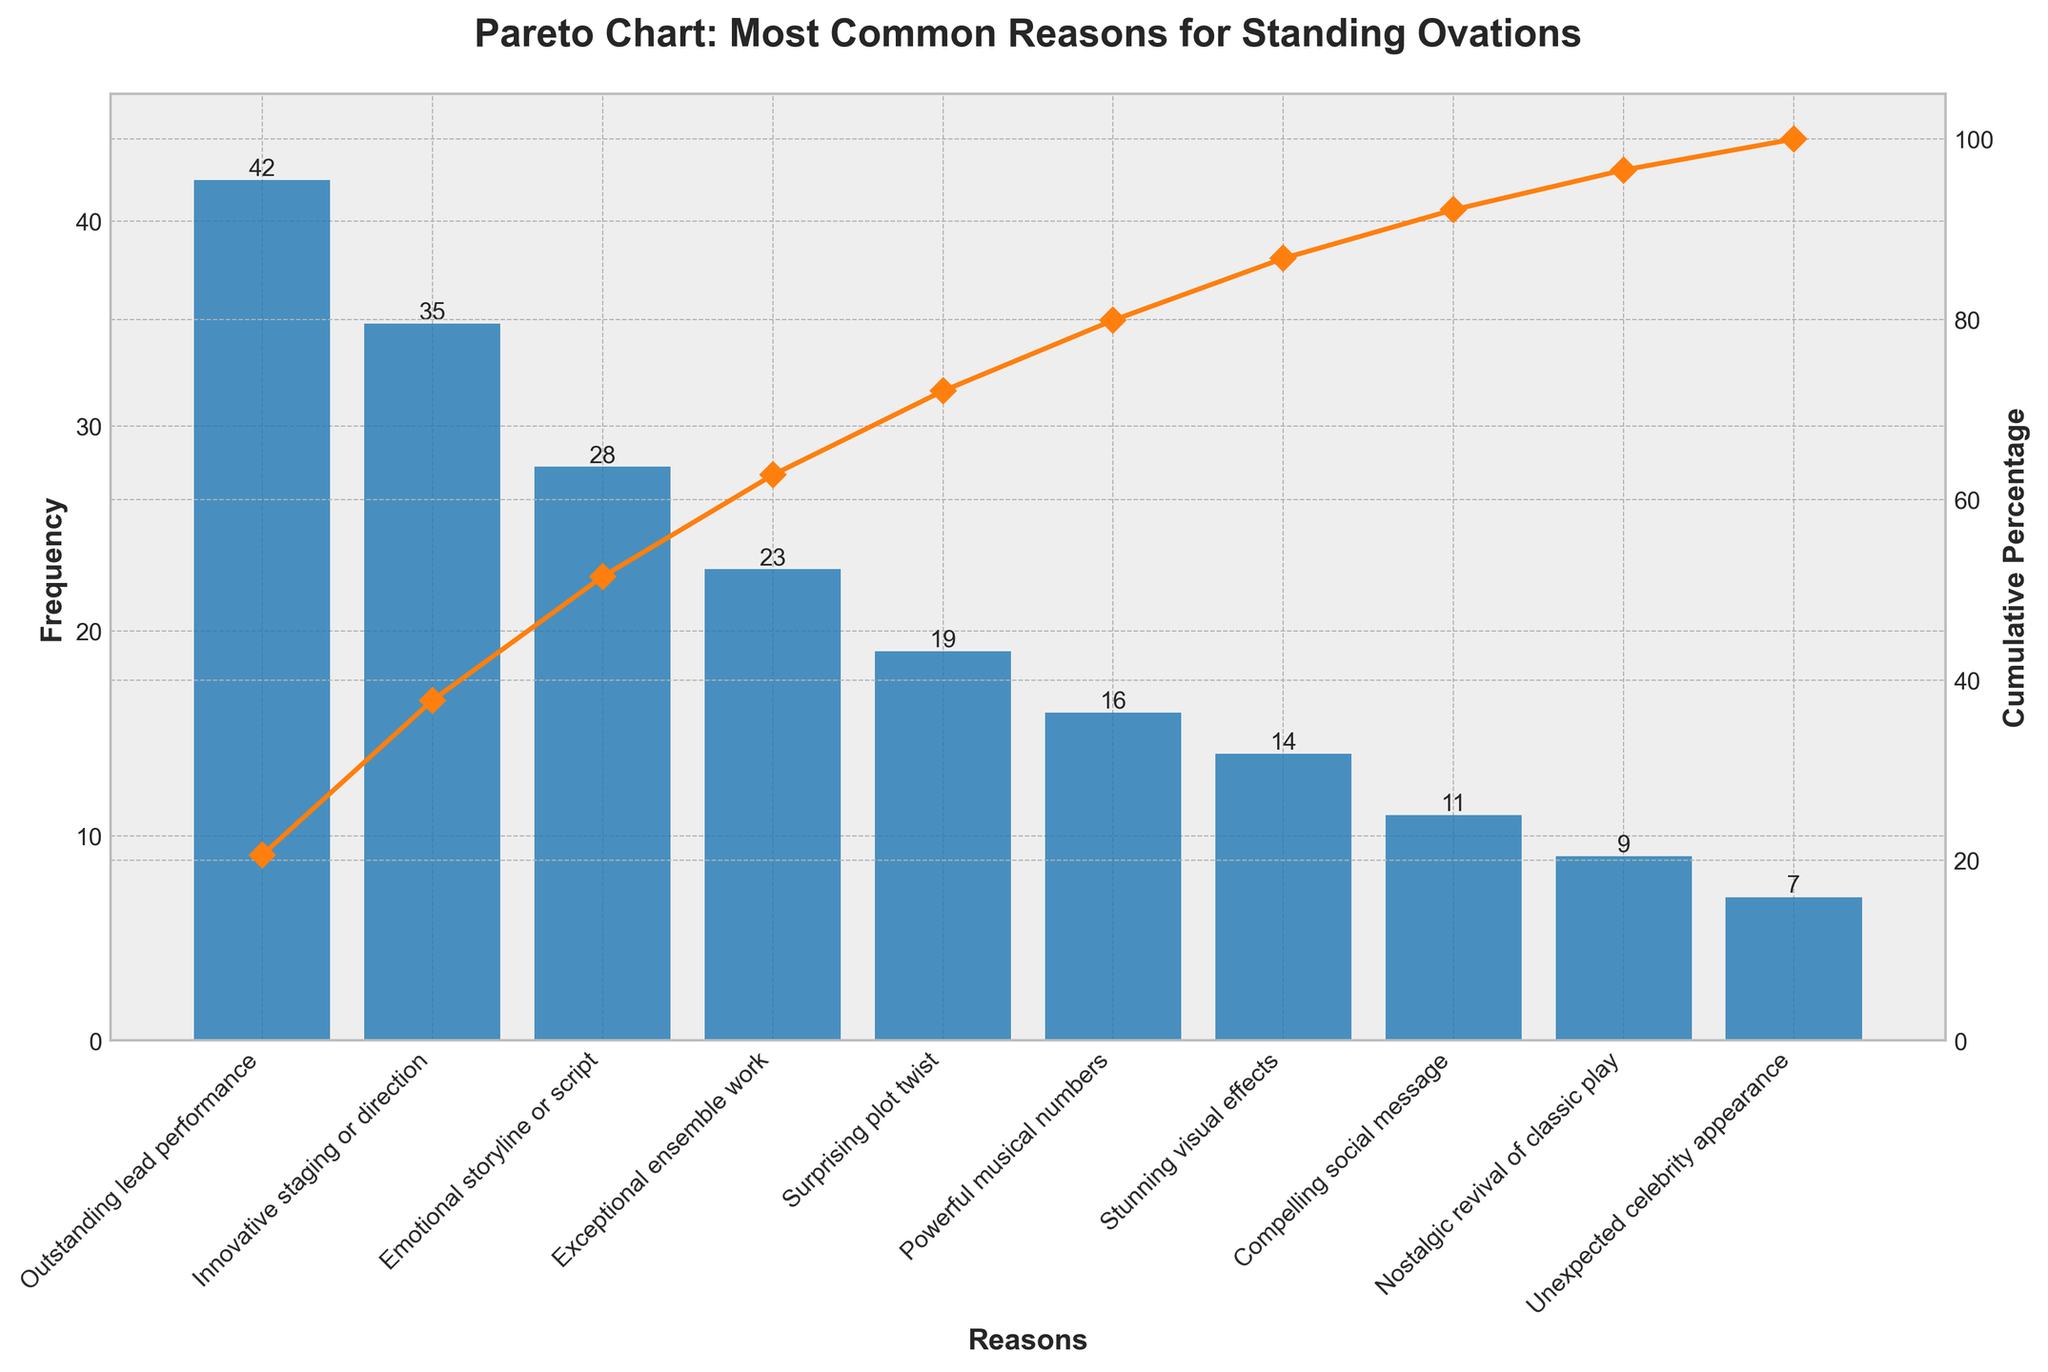What is the title of the chart? The title is displayed at the top of the graph in large, bold text.
Answer: Pareto Chart: Most Common Reasons for Standing Ovations What is the range of the cumulative percentage axis? The right y-axis denotes the cumulative percentage ranging from 0% to 105%.
Answer: 0% to 105% Which reason has the highest frequency for standing ovations? The highest bar on the chart represents the reason with the highest frequency.
Answer: Outstanding lead performance How many reasons account for more than 50% of the cumulative percentage? To find this, identify the reasons whose cumulative percentage sums up to just over 50%. It involves looking at the cumulative percentage line.
Answer: Three reasons What is the cumulative percentage after considering "Exceptional ensemble work"? Locate "Exceptional ensemble work" and observe the corresponding cumulative percentage from the line chart.
Answer: 84.1% Which has a higher frequency: "Stunning visual effects" or "Powerful musical numbers"? Compare the height of the bars corresponding to "Stunning visual effects" and "Powerful musical numbers".
Answer: Powerful musical numbers By how many does the frequency of "Outstanding lead performance" exceed that of "Emotional storyline or script"? Subtract the frequency of "Emotional storyline or script" from "Outstanding lead performance".
Answer: 14 What is the combined frequency of "Surprising plot twist" and "Unexpected celebrity appearance"? Add the frequency of "Surprising plot twist" and "Unexpected celebrity appearance" together.
Answer: 26 How many reasons have a frequency less than 20? Count the number of bars with a height (frequency) less than 20.
Answer: Six reasons What is the frequency difference between "Nostalgic revival of classic play" and the least common reason for standing ovations? Subtract the frequency of "Unexpected celebrity appearance" from "Nostalgic revival of classic play".
Answer: 2 